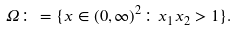<formula> <loc_0><loc_0><loc_500><loc_500>\Omega \colon = \{ x \in ( 0 , \infty ) ^ { 2 } \colon x _ { 1 } x _ { 2 } > 1 \} .</formula> 